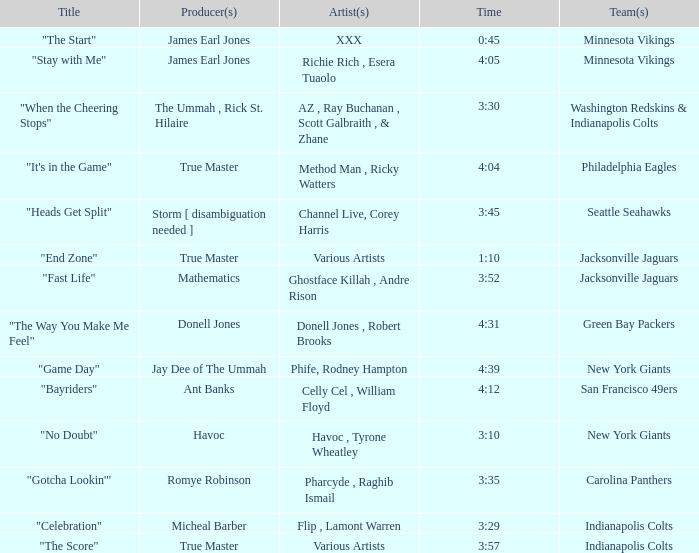What teams used a track 3:29 long? Indianapolis Colts. 